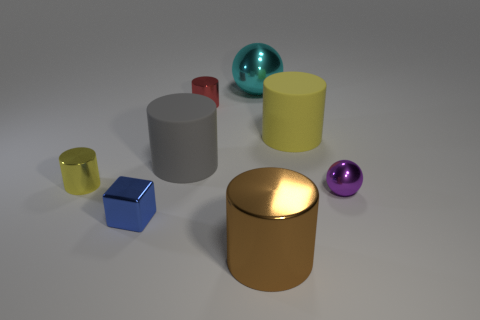Subtract all brown cylinders. How many cylinders are left? 4 Subtract all big yellow rubber cylinders. How many cylinders are left? 4 Subtract all blue cylinders. Subtract all yellow spheres. How many cylinders are left? 5 Add 1 yellow metallic objects. How many objects exist? 9 Subtract all spheres. How many objects are left? 6 Add 2 tiny gray metal objects. How many tiny gray metal objects exist? 2 Subtract 1 brown cylinders. How many objects are left? 7 Subtract all tiny yellow things. Subtract all small red metallic objects. How many objects are left? 6 Add 8 yellow rubber things. How many yellow rubber things are left? 9 